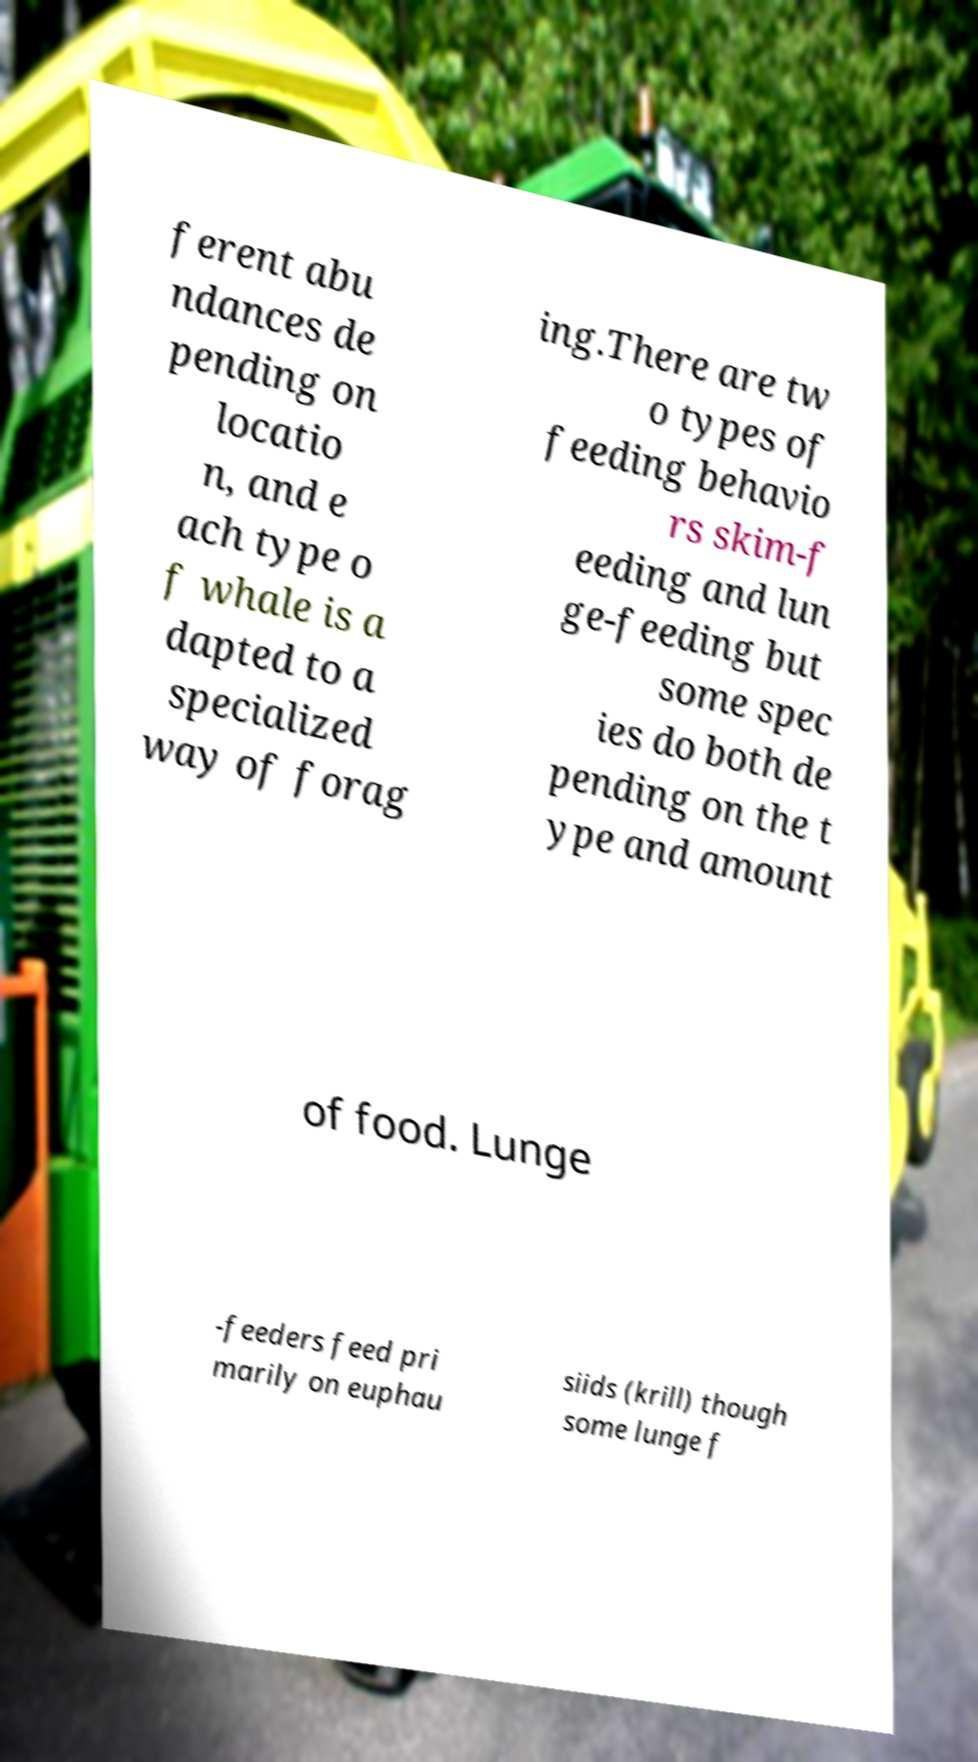Can you read and provide the text displayed in the image?This photo seems to have some interesting text. Can you extract and type it out for me? ferent abu ndances de pending on locatio n, and e ach type o f whale is a dapted to a specialized way of forag ing.There are tw o types of feeding behavio rs skim-f eeding and lun ge-feeding but some spec ies do both de pending on the t ype and amount of food. Lunge -feeders feed pri marily on euphau siids (krill) though some lunge f 